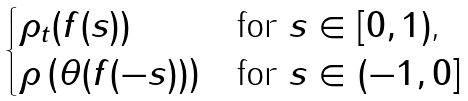<formula> <loc_0><loc_0><loc_500><loc_500>\begin{cases} \rho _ { t } ( f ( s ) ) & \text {for $s\in [0,1)$,} \\ \rho \left ( \theta ( f ( - s ) ) \right ) & \text {for $s\in (-1,0]$} \end{cases}</formula> 